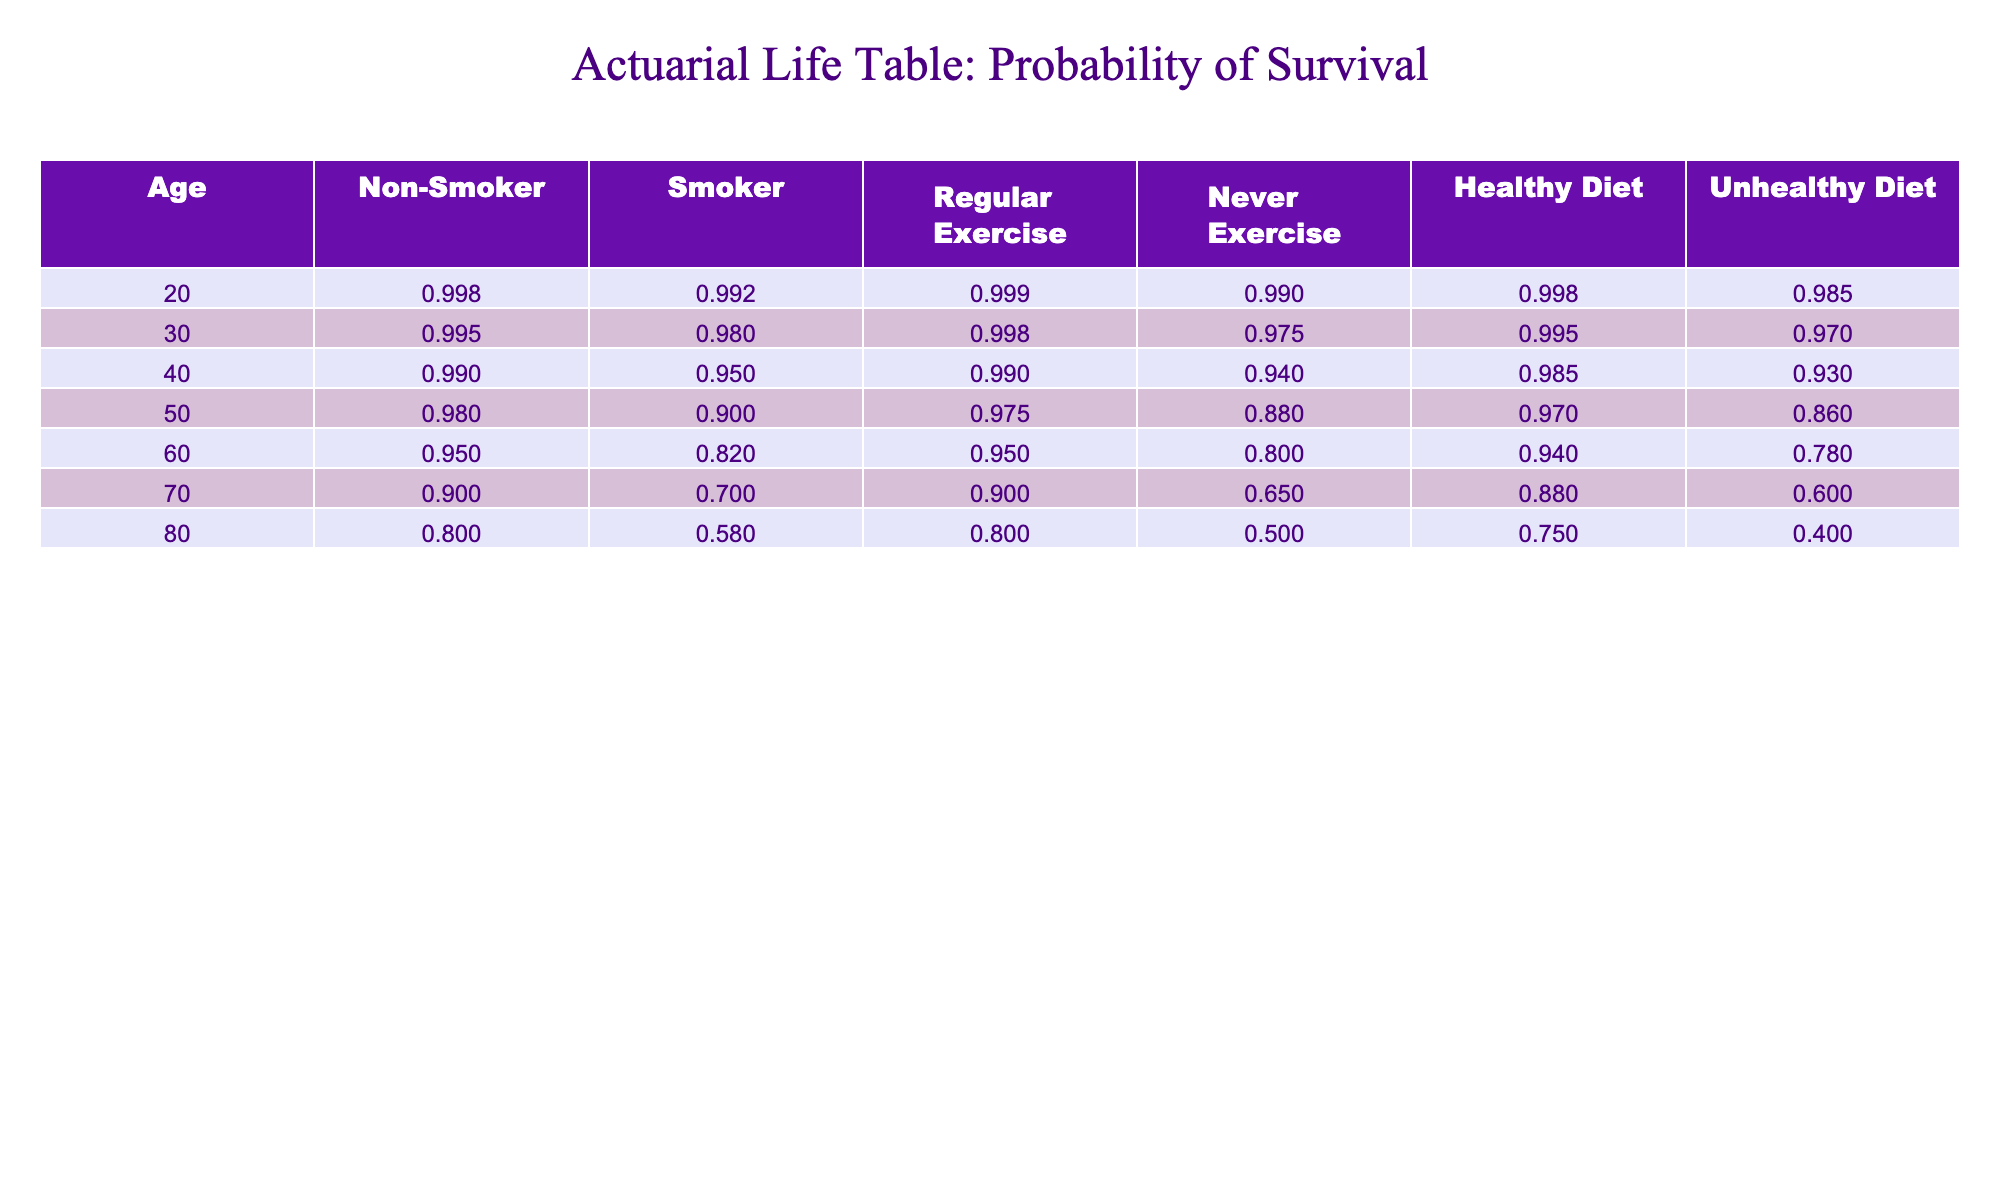What is the probability of a 40-year-old non-smoker surviving? The table shows that the probability of a 40-year-old non-smoker surviving is 0.990, as indicated in the 'Non-Smoker' column for age 40.
Answer: 0.990 What is the probability of survival for a 60-year-old who never exercises? According to the table, the probability of survival for a 60-year-old who never exercises is 0.800, found in the 'Never Exercise' column for age 60.
Answer: 0.800 How do the probabilities of survival for smokers and non-smokers compare at age 50? For age 50, the probability of a non-smoker surviving is 0.980, while that for a smoker is 0.900. The difference is 0.980 - 0.900 = 0.080, meaning non-smokers have a higher survival probability by 0.080.
Answer: Non-smokers have a higher survival probability by 0.080 Is the survival probability for individuals with a healthy diet higher or lower than for those with an unhealthy diet at age 70? At age 70, the survival probability for a healthy diet is 0.880 and for an unhealthy diet is 0.600. Since 0.880 > 0.600, the probability for a healthy diet is higher.
Answer: Higher What is the average survival probability for 30-year-olds across all lifestyle choices? The probabilities for 30-year-olds are: Non-Smoker (0.995), Smoker (0.980), Regular Exercise (0.998), Never Exercise (0.975), Healthy Diet (0.995), Unhealthy Diet (0.970). The sum is 0.995 + 0.980 + 0.998 + 0.975 + 0.995 + 0.970 = 5.913. With 6 data points, the average is 5.913 / 6 = 0.985.
Answer: 0.985 